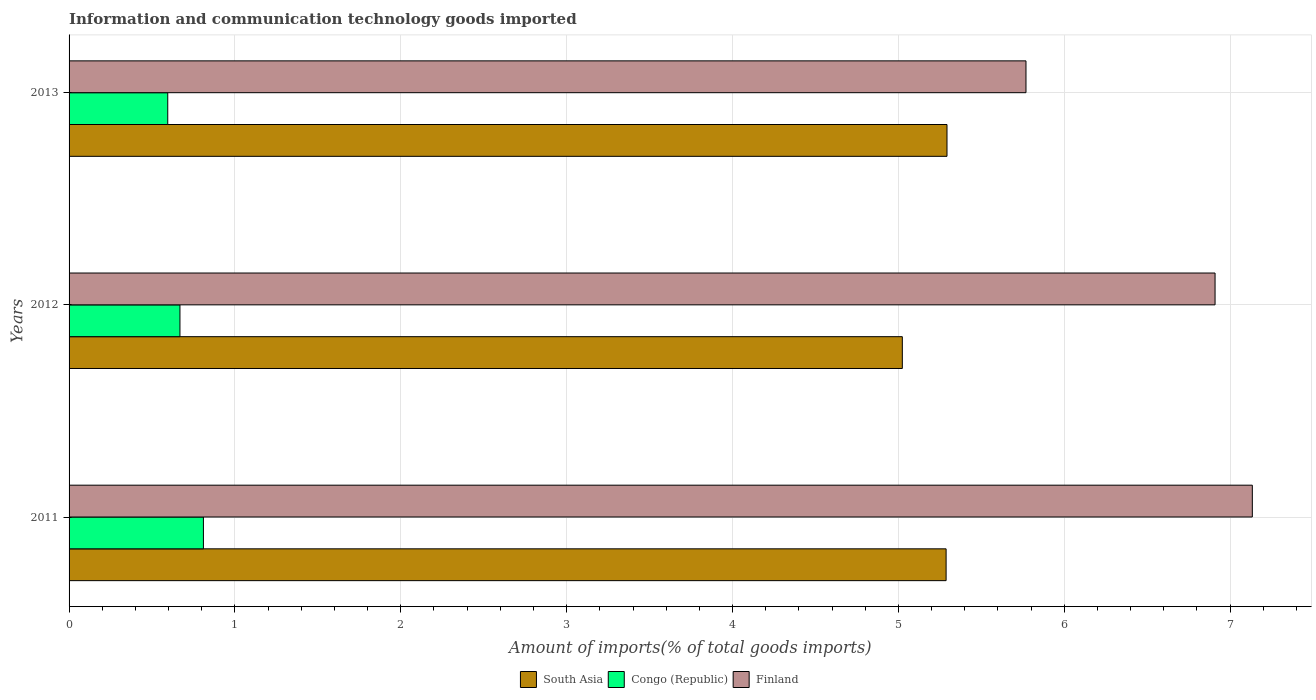Are the number of bars per tick equal to the number of legend labels?
Your answer should be compact. Yes. How many bars are there on the 3rd tick from the top?
Make the answer very short. 3. What is the label of the 1st group of bars from the top?
Your answer should be compact. 2013. What is the amount of goods imported in South Asia in 2013?
Make the answer very short. 5.29. Across all years, what is the maximum amount of goods imported in South Asia?
Your answer should be very brief. 5.29. Across all years, what is the minimum amount of goods imported in South Asia?
Make the answer very short. 5.02. In which year was the amount of goods imported in Finland minimum?
Make the answer very short. 2013. What is the total amount of goods imported in Congo (Republic) in the graph?
Your answer should be compact. 2.07. What is the difference between the amount of goods imported in South Asia in 2011 and that in 2013?
Provide a short and direct response. -0.01. What is the difference between the amount of goods imported in Finland in 2011 and the amount of goods imported in South Asia in 2013?
Your answer should be very brief. 1.84. What is the average amount of goods imported in South Asia per year?
Your answer should be very brief. 5.2. In the year 2012, what is the difference between the amount of goods imported in Finland and amount of goods imported in Congo (Republic)?
Provide a succinct answer. 6.24. What is the ratio of the amount of goods imported in Congo (Republic) in 2011 to that in 2012?
Your answer should be compact. 1.21. Is the amount of goods imported in Congo (Republic) in 2011 less than that in 2012?
Your response must be concise. No. What is the difference between the highest and the second highest amount of goods imported in Finland?
Offer a terse response. 0.22. What is the difference between the highest and the lowest amount of goods imported in South Asia?
Ensure brevity in your answer.  0.27. In how many years, is the amount of goods imported in South Asia greater than the average amount of goods imported in South Asia taken over all years?
Make the answer very short. 2. What does the 3rd bar from the top in 2011 represents?
Keep it short and to the point. South Asia. What does the 3rd bar from the bottom in 2013 represents?
Give a very brief answer. Finland. Is it the case that in every year, the sum of the amount of goods imported in Congo (Republic) and amount of goods imported in Finland is greater than the amount of goods imported in South Asia?
Make the answer very short. Yes. Are all the bars in the graph horizontal?
Provide a succinct answer. Yes. How many years are there in the graph?
Ensure brevity in your answer.  3. What is the title of the graph?
Offer a terse response. Information and communication technology goods imported. Does "Zambia" appear as one of the legend labels in the graph?
Provide a short and direct response. No. What is the label or title of the X-axis?
Your answer should be very brief. Amount of imports(% of total goods imports). What is the Amount of imports(% of total goods imports) of South Asia in 2011?
Ensure brevity in your answer.  5.29. What is the Amount of imports(% of total goods imports) of Congo (Republic) in 2011?
Keep it short and to the point. 0.81. What is the Amount of imports(% of total goods imports) in Finland in 2011?
Your answer should be compact. 7.13. What is the Amount of imports(% of total goods imports) of South Asia in 2012?
Your answer should be compact. 5.02. What is the Amount of imports(% of total goods imports) of Congo (Republic) in 2012?
Your answer should be very brief. 0.67. What is the Amount of imports(% of total goods imports) in Finland in 2012?
Your answer should be very brief. 6.91. What is the Amount of imports(% of total goods imports) in South Asia in 2013?
Keep it short and to the point. 5.29. What is the Amount of imports(% of total goods imports) in Congo (Republic) in 2013?
Keep it short and to the point. 0.59. What is the Amount of imports(% of total goods imports) of Finland in 2013?
Your answer should be compact. 5.77. Across all years, what is the maximum Amount of imports(% of total goods imports) in South Asia?
Provide a short and direct response. 5.29. Across all years, what is the maximum Amount of imports(% of total goods imports) in Congo (Republic)?
Make the answer very short. 0.81. Across all years, what is the maximum Amount of imports(% of total goods imports) of Finland?
Keep it short and to the point. 7.13. Across all years, what is the minimum Amount of imports(% of total goods imports) of South Asia?
Your answer should be compact. 5.02. Across all years, what is the minimum Amount of imports(% of total goods imports) of Congo (Republic)?
Offer a very short reply. 0.59. Across all years, what is the minimum Amount of imports(% of total goods imports) of Finland?
Ensure brevity in your answer.  5.77. What is the total Amount of imports(% of total goods imports) of South Asia in the graph?
Your answer should be compact. 15.6. What is the total Amount of imports(% of total goods imports) in Congo (Republic) in the graph?
Make the answer very short. 2.07. What is the total Amount of imports(% of total goods imports) of Finland in the graph?
Make the answer very short. 19.81. What is the difference between the Amount of imports(% of total goods imports) of South Asia in 2011 and that in 2012?
Provide a succinct answer. 0.26. What is the difference between the Amount of imports(% of total goods imports) in Congo (Republic) in 2011 and that in 2012?
Give a very brief answer. 0.14. What is the difference between the Amount of imports(% of total goods imports) in Finland in 2011 and that in 2012?
Your response must be concise. 0.22. What is the difference between the Amount of imports(% of total goods imports) in South Asia in 2011 and that in 2013?
Your answer should be very brief. -0.01. What is the difference between the Amount of imports(% of total goods imports) of Congo (Republic) in 2011 and that in 2013?
Your response must be concise. 0.21. What is the difference between the Amount of imports(% of total goods imports) in Finland in 2011 and that in 2013?
Ensure brevity in your answer.  1.36. What is the difference between the Amount of imports(% of total goods imports) of South Asia in 2012 and that in 2013?
Offer a terse response. -0.27. What is the difference between the Amount of imports(% of total goods imports) in Congo (Republic) in 2012 and that in 2013?
Your answer should be compact. 0.07. What is the difference between the Amount of imports(% of total goods imports) in Finland in 2012 and that in 2013?
Your answer should be very brief. 1.14. What is the difference between the Amount of imports(% of total goods imports) in South Asia in 2011 and the Amount of imports(% of total goods imports) in Congo (Republic) in 2012?
Provide a short and direct response. 4.62. What is the difference between the Amount of imports(% of total goods imports) of South Asia in 2011 and the Amount of imports(% of total goods imports) of Finland in 2012?
Provide a short and direct response. -1.62. What is the difference between the Amount of imports(% of total goods imports) of Congo (Republic) in 2011 and the Amount of imports(% of total goods imports) of Finland in 2012?
Provide a succinct answer. -6.1. What is the difference between the Amount of imports(% of total goods imports) in South Asia in 2011 and the Amount of imports(% of total goods imports) in Congo (Republic) in 2013?
Provide a short and direct response. 4.69. What is the difference between the Amount of imports(% of total goods imports) of South Asia in 2011 and the Amount of imports(% of total goods imports) of Finland in 2013?
Offer a very short reply. -0.48. What is the difference between the Amount of imports(% of total goods imports) of Congo (Republic) in 2011 and the Amount of imports(% of total goods imports) of Finland in 2013?
Offer a terse response. -4.96. What is the difference between the Amount of imports(% of total goods imports) of South Asia in 2012 and the Amount of imports(% of total goods imports) of Congo (Republic) in 2013?
Your answer should be very brief. 4.43. What is the difference between the Amount of imports(% of total goods imports) of South Asia in 2012 and the Amount of imports(% of total goods imports) of Finland in 2013?
Offer a very short reply. -0.75. What is the difference between the Amount of imports(% of total goods imports) of Congo (Republic) in 2012 and the Amount of imports(% of total goods imports) of Finland in 2013?
Offer a terse response. -5.1. What is the average Amount of imports(% of total goods imports) of South Asia per year?
Your answer should be compact. 5.2. What is the average Amount of imports(% of total goods imports) in Congo (Republic) per year?
Keep it short and to the point. 0.69. What is the average Amount of imports(% of total goods imports) in Finland per year?
Ensure brevity in your answer.  6.6. In the year 2011, what is the difference between the Amount of imports(% of total goods imports) of South Asia and Amount of imports(% of total goods imports) of Congo (Republic)?
Offer a terse response. 4.48. In the year 2011, what is the difference between the Amount of imports(% of total goods imports) of South Asia and Amount of imports(% of total goods imports) of Finland?
Give a very brief answer. -1.85. In the year 2011, what is the difference between the Amount of imports(% of total goods imports) in Congo (Republic) and Amount of imports(% of total goods imports) in Finland?
Provide a succinct answer. -6.32. In the year 2012, what is the difference between the Amount of imports(% of total goods imports) in South Asia and Amount of imports(% of total goods imports) in Congo (Republic)?
Offer a terse response. 4.36. In the year 2012, what is the difference between the Amount of imports(% of total goods imports) of South Asia and Amount of imports(% of total goods imports) of Finland?
Offer a terse response. -1.89. In the year 2012, what is the difference between the Amount of imports(% of total goods imports) of Congo (Republic) and Amount of imports(% of total goods imports) of Finland?
Offer a very short reply. -6.24. In the year 2013, what is the difference between the Amount of imports(% of total goods imports) of South Asia and Amount of imports(% of total goods imports) of Congo (Republic)?
Give a very brief answer. 4.7. In the year 2013, what is the difference between the Amount of imports(% of total goods imports) in South Asia and Amount of imports(% of total goods imports) in Finland?
Provide a short and direct response. -0.48. In the year 2013, what is the difference between the Amount of imports(% of total goods imports) in Congo (Republic) and Amount of imports(% of total goods imports) in Finland?
Keep it short and to the point. -5.17. What is the ratio of the Amount of imports(% of total goods imports) in South Asia in 2011 to that in 2012?
Your answer should be very brief. 1.05. What is the ratio of the Amount of imports(% of total goods imports) of Congo (Republic) in 2011 to that in 2012?
Your answer should be compact. 1.21. What is the ratio of the Amount of imports(% of total goods imports) in Finland in 2011 to that in 2012?
Your response must be concise. 1.03. What is the ratio of the Amount of imports(% of total goods imports) in Congo (Republic) in 2011 to that in 2013?
Provide a short and direct response. 1.36. What is the ratio of the Amount of imports(% of total goods imports) of Finland in 2011 to that in 2013?
Your answer should be very brief. 1.24. What is the ratio of the Amount of imports(% of total goods imports) of South Asia in 2012 to that in 2013?
Provide a succinct answer. 0.95. What is the ratio of the Amount of imports(% of total goods imports) in Congo (Republic) in 2012 to that in 2013?
Make the answer very short. 1.12. What is the ratio of the Amount of imports(% of total goods imports) in Finland in 2012 to that in 2013?
Offer a very short reply. 1.2. What is the difference between the highest and the second highest Amount of imports(% of total goods imports) in South Asia?
Keep it short and to the point. 0.01. What is the difference between the highest and the second highest Amount of imports(% of total goods imports) in Congo (Republic)?
Give a very brief answer. 0.14. What is the difference between the highest and the second highest Amount of imports(% of total goods imports) in Finland?
Ensure brevity in your answer.  0.22. What is the difference between the highest and the lowest Amount of imports(% of total goods imports) in South Asia?
Provide a short and direct response. 0.27. What is the difference between the highest and the lowest Amount of imports(% of total goods imports) of Congo (Republic)?
Your answer should be compact. 0.21. What is the difference between the highest and the lowest Amount of imports(% of total goods imports) in Finland?
Provide a short and direct response. 1.36. 